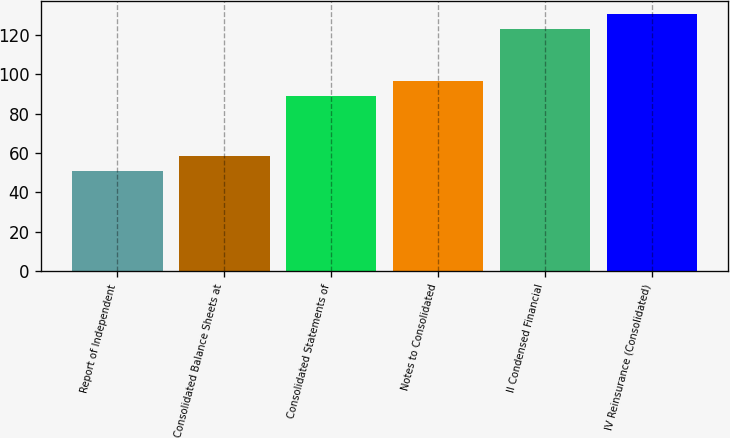<chart> <loc_0><loc_0><loc_500><loc_500><bar_chart><fcel>Report of Independent<fcel>Consolidated Balance Sheets at<fcel>Consolidated Statements of<fcel>Notes to Consolidated<fcel>II Condensed Financial<fcel>IV Reinsurance (Consolidated)<nl><fcel>51<fcel>58.6<fcel>89<fcel>96.6<fcel>123<fcel>130.6<nl></chart> 